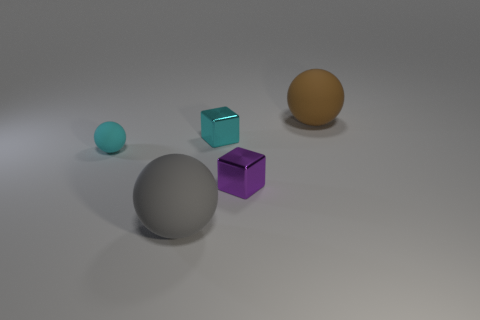Subtract all large gray balls. How many balls are left? 2 Add 3 brown spheres. How many objects exist? 8 Subtract all balls. How many objects are left? 2 Subtract all yellow balls. Subtract all gray cubes. How many balls are left? 3 Add 1 small matte balls. How many small matte balls exist? 2 Subtract 0 gray blocks. How many objects are left? 5 Subtract all tiny cyan rubber things. Subtract all large things. How many objects are left? 2 Add 3 cyan matte spheres. How many cyan matte spheres are left? 4 